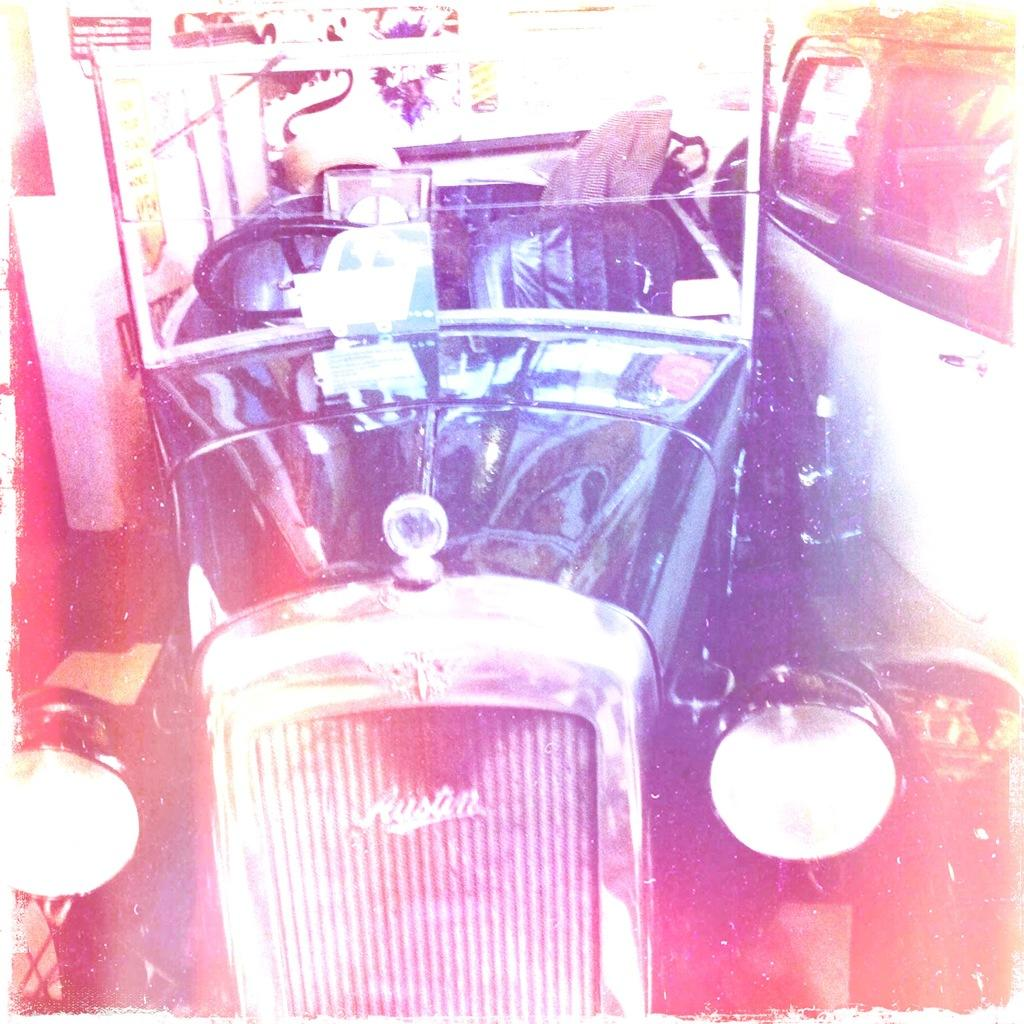What colors are the vehicles in the image? There is a black vehicle and a white vehicle in the image. What can be seen in the background of the image? The background of the image is white. What type of kite is being flown by the person in the image? There is no person or kite present in the image; it only features two vehicles. 